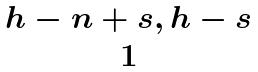Convert formula to latex. <formula><loc_0><loc_0><loc_500><loc_500>\begin{matrix} { h - n + s , h - s } \\ { 1 } \end{matrix}</formula> 